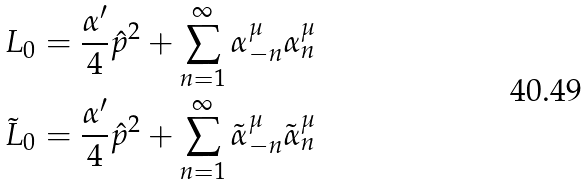Convert formula to latex. <formula><loc_0><loc_0><loc_500><loc_500>L _ { 0 } & = \frac { \alpha ^ { \prime } } { 4 } \hat { p } ^ { 2 } + \sum _ { n = 1 } ^ { \infty } \alpha _ { - n } ^ { \mu } \alpha _ { n } ^ { \mu } \\ \tilde { L } _ { 0 } & = \frac { \alpha ^ { \prime } } { 4 } \hat { p } ^ { 2 } + \sum _ { n = 1 } ^ { \infty } \tilde { \alpha } _ { - n } ^ { \mu } \tilde { \alpha } _ { n } ^ { \mu }</formula> 